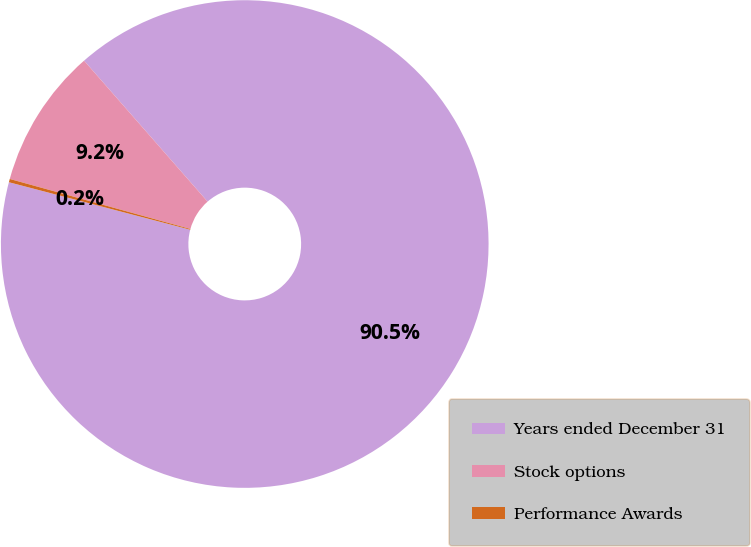Convert chart to OTSL. <chart><loc_0><loc_0><loc_500><loc_500><pie_chart><fcel>Years ended December 31<fcel>Stock options<fcel>Performance Awards<nl><fcel>90.53%<fcel>9.25%<fcel>0.22%<nl></chart> 